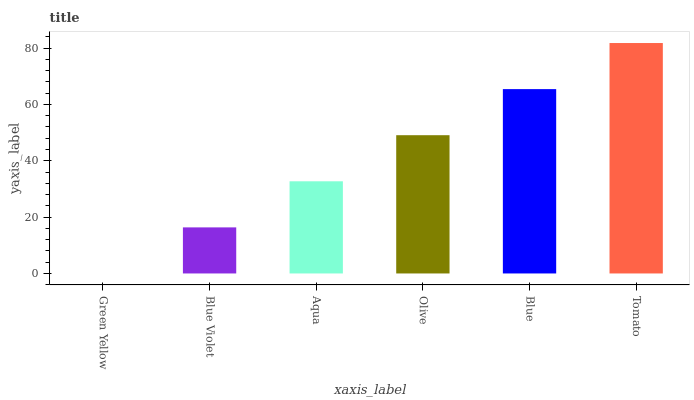Is Blue Violet the minimum?
Answer yes or no. No. Is Blue Violet the maximum?
Answer yes or no. No. Is Blue Violet greater than Green Yellow?
Answer yes or no. Yes. Is Green Yellow less than Blue Violet?
Answer yes or no. Yes. Is Green Yellow greater than Blue Violet?
Answer yes or no. No. Is Blue Violet less than Green Yellow?
Answer yes or no. No. Is Olive the high median?
Answer yes or no. Yes. Is Aqua the low median?
Answer yes or no. Yes. Is Green Yellow the high median?
Answer yes or no. No. Is Tomato the low median?
Answer yes or no. No. 